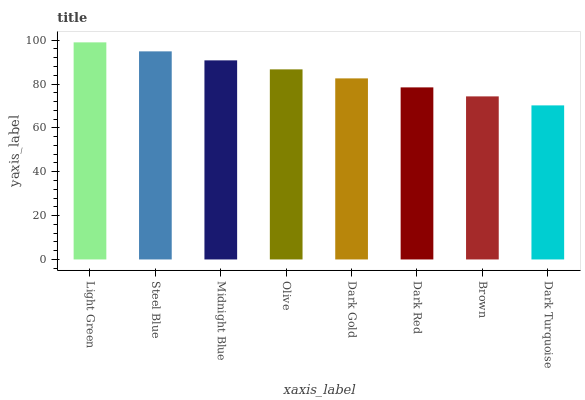Is Dark Turquoise the minimum?
Answer yes or no. Yes. Is Light Green the maximum?
Answer yes or no. Yes. Is Steel Blue the minimum?
Answer yes or no. No. Is Steel Blue the maximum?
Answer yes or no. No. Is Light Green greater than Steel Blue?
Answer yes or no. Yes. Is Steel Blue less than Light Green?
Answer yes or no. Yes. Is Steel Blue greater than Light Green?
Answer yes or no. No. Is Light Green less than Steel Blue?
Answer yes or no. No. Is Olive the high median?
Answer yes or no. Yes. Is Dark Gold the low median?
Answer yes or no. Yes. Is Light Green the high median?
Answer yes or no. No. Is Dark Turquoise the low median?
Answer yes or no. No. 